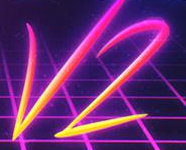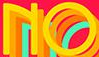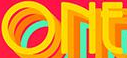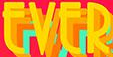Transcribe the words shown in these images in order, separated by a semicolon. V2; NO; ONE; EVER 